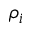Convert formula to latex. <formula><loc_0><loc_0><loc_500><loc_500>\rho _ { i }</formula> 